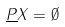Convert formula to latex. <formula><loc_0><loc_0><loc_500><loc_500>\underline { P } X = \emptyset</formula> 